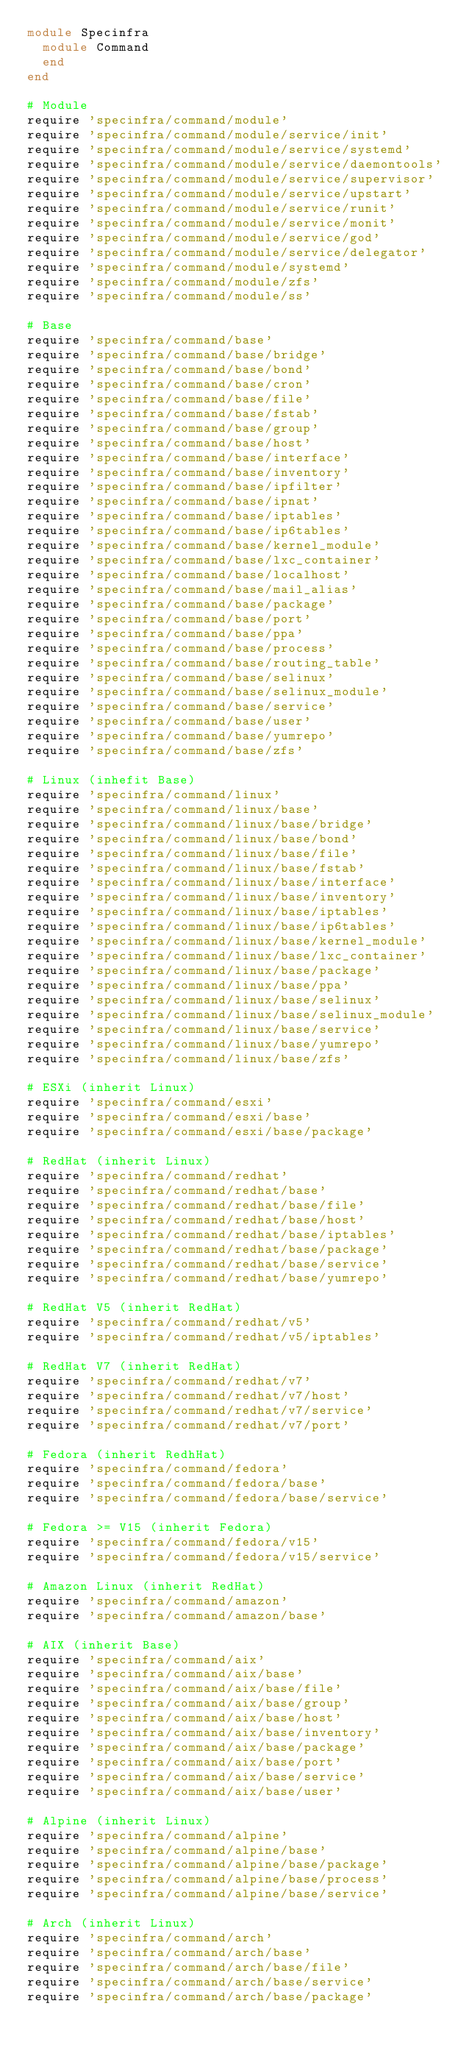<code> <loc_0><loc_0><loc_500><loc_500><_Ruby_>module Specinfra
  module Command
  end
end

# Module
require 'specinfra/command/module'
require 'specinfra/command/module/service/init'
require 'specinfra/command/module/service/systemd'
require 'specinfra/command/module/service/daemontools'
require 'specinfra/command/module/service/supervisor'
require 'specinfra/command/module/service/upstart'
require 'specinfra/command/module/service/runit'
require 'specinfra/command/module/service/monit'
require 'specinfra/command/module/service/god'
require 'specinfra/command/module/service/delegator'
require 'specinfra/command/module/systemd'
require 'specinfra/command/module/zfs'
require 'specinfra/command/module/ss'

# Base
require 'specinfra/command/base'
require 'specinfra/command/base/bridge'
require 'specinfra/command/base/bond'
require 'specinfra/command/base/cron'
require 'specinfra/command/base/file'
require 'specinfra/command/base/fstab'
require 'specinfra/command/base/group'
require 'specinfra/command/base/host'
require 'specinfra/command/base/interface'
require 'specinfra/command/base/inventory'
require 'specinfra/command/base/ipfilter'
require 'specinfra/command/base/ipnat'
require 'specinfra/command/base/iptables'
require 'specinfra/command/base/ip6tables'
require 'specinfra/command/base/kernel_module'
require 'specinfra/command/base/lxc_container'
require 'specinfra/command/base/localhost'
require 'specinfra/command/base/mail_alias'
require 'specinfra/command/base/package'
require 'specinfra/command/base/port'
require 'specinfra/command/base/ppa'
require 'specinfra/command/base/process'
require 'specinfra/command/base/routing_table'
require 'specinfra/command/base/selinux'
require 'specinfra/command/base/selinux_module'
require 'specinfra/command/base/service'
require 'specinfra/command/base/user'
require 'specinfra/command/base/yumrepo'
require 'specinfra/command/base/zfs'

# Linux (inhefit Base)
require 'specinfra/command/linux'
require 'specinfra/command/linux/base'
require 'specinfra/command/linux/base/bridge'
require 'specinfra/command/linux/base/bond'
require 'specinfra/command/linux/base/file'
require 'specinfra/command/linux/base/fstab'
require 'specinfra/command/linux/base/interface'
require 'specinfra/command/linux/base/inventory'
require 'specinfra/command/linux/base/iptables'
require 'specinfra/command/linux/base/ip6tables'
require 'specinfra/command/linux/base/kernel_module'
require 'specinfra/command/linux/base/lxc_container'
require 'specinfra/command/linux/base/package'
require 'specinfra/command/linux/base/ppa'
require 'specinfra/command/linux/base/selinux'
require 'specinfra/command/linux/base/selinux_module'
require 'specinfra/command/linux/base/service'
require 'specinfra/command/linux/base/yumrepo'
require 'specinfra/command/linux/base/zfs'

# ESXi (inherit Linux)
require 'specinfra/command/esxi'
require 'specinfra/command/esxi/base'
require 'specinfra/command/esxi/base/package'

# RedHat (inherit Linux)
require 'specinfra/command/redhat'
require 'specinfra/command/redhat/base'
require 'specinfra/command/redhat/base/file'
require 'specinfra/command/redhat/base/host'
require 'specinfra/command/redhat/base/iptables'
require 'specinfra/command/redhat/base/package'
require 'specinfra/command/redhat/base/service'
require 'specinfra/command/redhat/base/yumrepo'

# RedHat V5 (inherit RedHat)
require 'specinfra/command/redhat/v5'
require 'specinfra/command/redhat/v5/iptables'

# RedHat V7 (inherit RedHat)
require 'specinfra/command/redhat/v7'
require 'specinfra/command/redhat/v7/host'
require 'specinfra/command/redhat/v7/service'
require 'specinfra/command/redhat/v7/port'

# Fedora (inherit RedhHat)
require 'specinfra/command/fedora'
require 'specinfra/command/fedora/base'
require 'specinfra/command/fedora/base/service'

# Fedora >= V15 (inherit Fedora)
require 'specinfra/command/fedora/v15'
require 'specinfra/command/fedora/v15/service'

# Amazon Linux (inherit RedHat)
require 'specinfra/command/amazon'
require 'specinfra/command/amazon/base'

# AIX (inherit Base)
require 'specinfra/command/aix'
require 'specinfra/command/aix/base'
require 'specinfra/command/aix/base/file'
require 'specinfra/command/aix/base/group'
require 'specinfra/command/aix/base/host'
require 'specinfra/command/aix/base/inventory'
require 'specinfra/command/aix/base/package'
require 'specinfra/command/aix/base/port'
require 'specinfra/command/aix/base/service'
require 'specinfra/command/aix/base/user'

# Alpine (inherit Linux)
require 'specinfra/command/alpine'
require 'specinfra/command/alpine/base'
require 'specinfra/command/alpine/base/package'
require 'specinfra/command/alpine/base/process'
require 'specinfra/command/alpine/base/service'

# Arch (inherit Linux)
require 'specinfra/command/arch'
require 'specinfra/command/arch/base'
require 'specinfra/command/arch/base/file'
require 'specinfra/command/arch/base/service'
require 'specinfra/command/arch/base/package'
</code> 